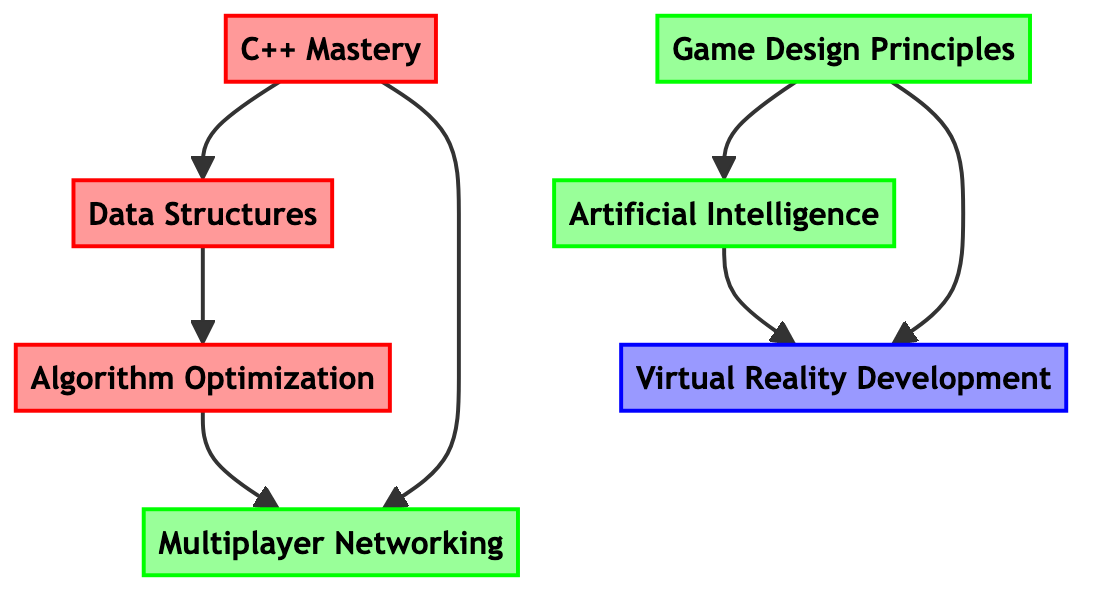What is the first skill in the skill tree? The first skill is at the top of the directed graph and has no prerequisites, which is "C++ Mastery."
Answer: C++ Mastery How many total skills are there in the diagram? By counting all the individual skill nodes in the directed graph, there are seven skills shown in total.
Answer: Seven What skill must be learned before "Algorithm Optimization"? The directed edge points from "Data Structures" to "Algorithm Optimization," indicating that "Data Structures" is a prerequisite.
Answer: Data Structures Which skills lead to "Multiplayer Networking"? The directed graph shows that both "C++ Mastery" and "Algorithm Optimization" have directed edges pointing to "Multiplayer Networking," implying these are the skills required.
Answer: C++ Mastery, Algorithm Optimization What type of skill is "Virtual Reality Development"? Looking at the classification provided in the diagram, "Virtual Reality Development" is categorized as an "Expert Skill."
Answer: Expert Skill Which skill has the most prerequisites? To determine this, we examine the directed edges; "Virtual Reality Development" is dependent on two skills "Artificial Intelligence" and "Game Design Principles," making it the skill with the most prerequisites.
Answer: Virtual Reality Development How are "Game Design Principles" and "Artificial Intelligence" related in the graph? "Game Design Principles" is a prerequisite for "Artificial Intelligence," indicated by a directed edge pointing to it from "Game Design Principles."
Answer: Prerequisite relationship Which core skill has no prerequisites? The knowledge of the diagram reveals that "C++ Mastery" is the only core skill with no skills preceding it.
Answer: C++ Mastery 